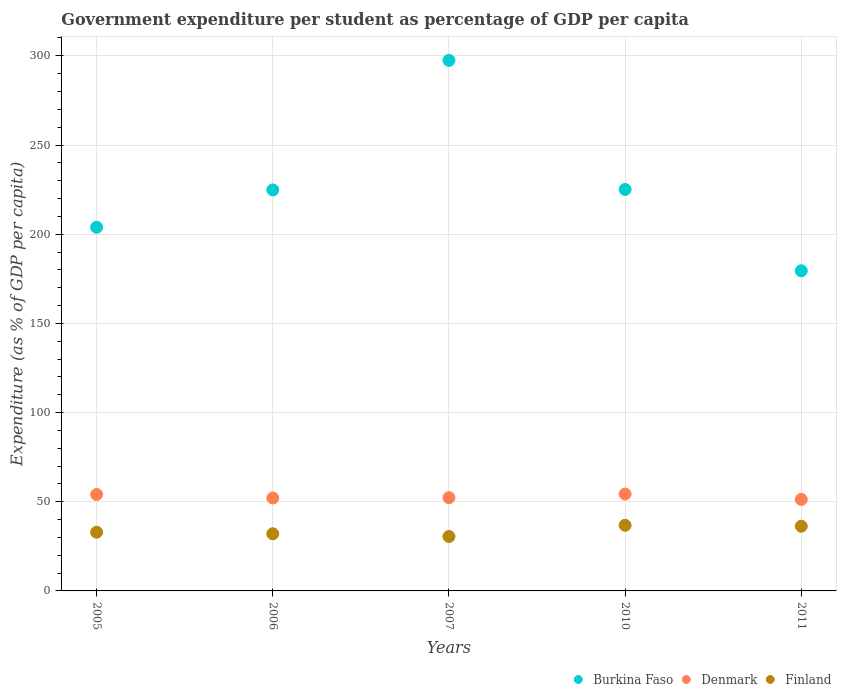How many different coloured dotlines are there?
Give a very brief answer. 3. Is the number of dotlines equal to the number of legend labels?
Your answer should be very brief. Yes. What is the percentage of expenditure per student in Finland in 2006?
Give a very brief answer. 32.04. Across all years, what is the maximum percentage of expenditure per student in Finland?
Your response must be concise. 36.8. Across all years, what is the minimum percentage of expenditure per student in Denmark?
Ensure brevity in your answer.  51.31. In which year was the percentage of expenditure per student in Burkina Faso minimum?
Keep it short and to the point. 2011. What is the total percentage of expenditure per student in Denmark in the graph?
Keep it short and to the point. 264.11. What is the difference between the percentage of expenditure per student in Finland in 2005 and that in 2006?
Give a very brief answer. 0.88. What is the difference between the percentage of expenditure per student in Finland in 2006 and the percentage of expenditure per student in Burkina Faso in 2011?
Ensure brevity in your answer.  -147.44. What is the average percentage of expenditure per student in Burkina Faso per year?
Keep it short and to the point. 226.14. In the year 2011, what is the difference between the percentage of expenditure per student in Denmark and percentage of expenditure per student in Burkina Faso?
Make the answer very short. -128.17. In how many years, is the percentage of expenditure per student in Burkina Faso greater than 230 %?
Your response must be concise. 1. What is the ratio of the percentage of expenditure per student in Denmark in 2010 to that in 2011?
Make the answer very short. 1.06. Is the percentage of expenditure per student in Finland in 2005 less than that in 2011?
Provide a short and direct response. Yes. Is the difference between the percentage of expenditure per student in Denmark in 2007 and 2010 greater than the difference between the percentage of expenditure per student in Burkina Faso in 2007 and 2010?
Offer a terse response. No. What is the difference between the highest and the second highest percentage of expenditure per student in Denmark?
Give a very brief answer. 0.23. What is the difference between the highest and the lowest percentage of expenditure per student in Denmark?
Your answer should be compact. 3.01. In how many years, is the percentage of expenditure per student in Finland greater than the average percentage of expenditure per student in Finland taken over all years?
Keep it short and to the point. 2. Is it the case that in every year, the sum of the percentage of expenditure per student in Burkina Faso and percentage of expenditure per student in Denmark  is greater than the percentage of expenditure per student in Finland?
Make the answer very short. Yes. Is the percentage of expenditure per student in Denmark strictly greater than the percentage of expenditure per student in Burkina Faso over the years?
Your answer should be compact. No. Is the percentage of expenditure per student in Burkina Faso strictly less than the percentage of expenditure per student in Finland over the years?
Offer a terse response. No. Does the graph contain any zero values?
Your response must be concise. No. What is the title of the graph?
Your answer should be very brief. Government expenditure per student as percentage of GDP per capita. Does "Greece" appear as one of the legend labels in the graph?
Keep it short and to the point. No. What is the label or title of the Y-axis?
Offer a very short reply. Expenditure (as % of GDP per capita). What is the Expenditure (as % of GDP per capita) of Burkina Faso in 2005?
Your answer should be compact. 203.88. What is the Expenditure (as % of GDP per capita) of Denmark in 2005?
Provide a short and direct response. 54.09. What is the Expenditure (as % of GDP per capita) in Finland in 2005?
Give a very brief answer. 32.92. What is the Expenditure (as % of GDP per capita) in Burkina Faso in 2006?
Offer a very short reply. 224.82. What is the Expenditure (as % of GDP per capita) of Denmark in 2006?
Make the answer very short. 52.1. What is the Expenditure (as % of GDP per capita) of Finland in 2006?
Your answer should be very brief. 32.04. What is the Expenditure (as % of GDP per capita) of Burkina Faso in 2007?
Give a very brief answer. 297.45. What is the Expenditure (as % of GDP per capita) in Denmark in 2007?
Ensure brevity in your answer.  52.29. What is the Expenditure (as % of GDP per capita) in Finland in 2007?
Provide a succinct answer. 30.51. What is the Expenditure (as % of GDP per capita) in Burkina Faso in 2010?
Your answer should be compact. 225.08. What is the Expenditure (as % of GDP per capita) in Denmark in 2010?
Ensure brevity in your answer.  54.32. What is the Expenditure (as % of GDP per capita) in Finland in 2010?
Your answer should be compact. 36.8. What is the Expenditure (as % of GDP per capita) of Burkina Faso in 2011?
Provide a short and direct response. 179.48. What is the Expenditure (as % of GDP per capita) of Denmark in 2011?
Provide a short and direct response. 51.31. What is the Expenditure (as % of GDP per capita) of Finland in 2011?
Provide a succinct answer. 36.27. Across all years, what is the maximum Expenditure (as % of GDP per capita) of Burkina Faso?
Your response must be concise. 297.45. Across all years, what is the maximum Expenditure (as % of GDP per capita) of Denmark?
Give a very brief answer. 54.32. Across all years, what is the maximum Expenditure (as % of GDP per capita) in Finland?
Your answer should be very brief. 36.8. Across all years, what is the minimum Expenditure (as % of GDP per capita) in Burkina Faso?
Your answer should be very brief. 179.48. Across all years, what is the minimum Expenditure (as % of GDP per capita) of Denmark?
Make the answer very short. 51.31. Across all years, what is the minimum Expenditure (as % of GDP per capita) of Finland?
Offer a very short reply. 30.51. What is the total Expenditure (as % of GDP per capita) in Burkina Faso in the graph?
Your answer should be compact. 1130.71. What is the total Expenditure (as % of GDP per capita) in Denmark in the graph?
Ensure brevity in your answer.  264.11. What is the total Expenditure (as % of GDP per capita) in Finland in the graph?
Your answer should be very brief. 168.54. What is the difference between the Expenditure (as % of GDP per capita) of Burkina Faso in 2005 and that in 2006?
Your answer should be compact. -20.94. What is the difference between the Expenditure (as % of GDP per capita) of Denmark in 2005 and that in 2006?
Your answer should be compact. 1.99. What is the difference between the Expenditure (as % of GDP per capita) in Finland in 2005 and that in 2006?
Give a very brief answer. 0.88. What is the difference between the Expenditure (as % of GDP per capita) in Burkina Faso in 2005 and that in 2007?
Keep it short and to the point. -93.57. What is the difference between the Expenditure (as % of GDP per capita) in Denmark in 2005 and that in 2007?
Your response must be concise. 1.8. What is the difference between the Expenditure (as % of GDP per capita) of Finland in 2005 and that in 2007?
Your answer should be compact. 2.41. What is the difference between the Expenditure (as % of GDP per capita) in Burkina Faso in 2005 and that in 2010?
Your response must be concise. -21.21. What is the difference between the Expenditure (as % of GDP per capita) in Denmark in 2005 and that in 2010?
Your answer should be very brief. -0.23. What is the difference between the Expenditure (as % of GDP per capita) in Finland in 2005 and that in 2010?
Your response must be concise. -3.89. What is the difference between the Expenditure (as % of GDP per capita) in Burkina Faso in 2005 and that in 2011?
Provide a short and direct response. 24.4. What is the difference between the Expenditure (as % of GDP per capita) of Denmark in 2005 and that in 2011?
Provide a short and direct response. 2.78. What is the difference between the Expenditure (as % of GDP per capita) of Finland in 2005 and that in 2011?
Ensure brevity in your answer.  -3.36. What is the difference between the Expenditure (as % of GDP per capita) in Burkina Faso in 2006 and that in 2007?
Give a very brief answer. -72.63. What is the difference between the Expenditure (as % of GDP per capita) of Denmark in 2006 and that in 2007?
Give a very brief answer. -0.19. What is the difference between the Expenditure (as % of GDP per capita) in Finland in 2006 and that in 2007?
Keep it short and to the point. 1.53. What is the difference between the Expenditure (as % of GDP per capita) in Burkina Faso in 2006 and that in 2010?
Provide a succinct answer. -0.26. What is the difference between the Expenditure (as % of GDP per capita) of Denmark in 2006 and that in 2010?
Give a very brief answer. -2.22. What is the difference between the Expenditure (as % of GDP per capita) in Finland in 2006 and that in 2010?
Provide a succinct answer. -4.77. What is the difference between the Expenditure (as % of GDP per capita) in Burkina Faso in 2006 and that in 2011?
Make the answer very short. 45.34. What is the difference between the Expenditure (as % of GDP per capita) of Denmark in 2006 and that in 2011?
Make the answer very short. 0.79. What is the difference between the Expenditure (as % of GDP per capita) of Finland in 2006 and that in 2011?
Provide a succinct answer. -4.24. What is the difference between the Expenditure (as % of GDP per capita) in Burkina Faso in 2007 and that in 2010?
Your answer should be very brief. 72.37. What is the difference between the Expenditure (as % of GDP per capita) of Denmark in 2007 and that in 2010?
Your answer should be very brief. -2.03. What is the difference between the Expenditure (as % of GDP per capita) in Finland in 2007 and that in 2010?
Give a very brief answer. -6.3. What is the difference between the Expenditure (as % of GDP per capita) of Burkina Faso in 2007 and that in 2011?
Your answer should be compact. 117.97. What is the difference between the Expenditure (as % of GDP per capita) of Denmark in 2007 and that in 2011?
Ensure brevity in your answer.  0.98. What is the difference between the Expenditure (as % of GDP per capita) of Finland in 2007 and that in 2011?
Keep it short and to the point. -5.77. What is the difference between the Expenditure (as % of GDP per capita) of Burkina Faso in 2010 and that in 2011?
Your answer should be very brief. 45.6. What is the difference between the Expenditure (as % of GDP per capita) of Denmark in 2010 and that in 2011?
Ensure brevity in your answer.  3.01. What is the difference between the Expenditure (as % of GDP per capita) in Finland in 2010 and that in 2011?
Keep it short and to the point. 0.53. What is the difference between the Expenditure (as % of GDP per capita) in Burkina Faso in 2005 and the Expenditure (as % of GDP per capita) in Denmark in 2006?
Offer a very short reply. 151.78. What is the difference between the Expenditure (as % of GDP per capita) in Burkina Faso in 2005 and the Expenditure (as % of GDP per capita) in Finland in 2006?
Provide a short and direct response. 171.84. What is the difference between the Expenditure (as % of GDP per capita) of Denmark in 2005 and the Expenditure (as % of GDP per capita) of Finland in 2006?
Provide a short and direct response. 22.05. What is the difference between the Expenditure (as % of GDP per capita) of Burkina Faso in 2005 and the Expenditure (as % of GDP per capita) of Denmark in 2007?
Your answer should be compact. 151.59. What is the difference between the Expenditure (as % of GDP per capita) in Burkina Faso in 2005 and the Expenditure (as % of GDP per capita) in Finland in 2007?
Keep it short and to the point. 173.37. What is the difference between the Expenditure (as % of GDP per capita) of Denmark in 2005 and the Expenditure (as % of GDP per capita) of Finland in 2007?
Provide a short and direct response. 23.58. What is the difference between the Expenditure (as % of GDP per capita) of Burkina Faso in 2005 and the Expenditure (as % of GDP per capita) of Denmark in 2010?
Provide a succinct answer. 149.56. What is the difference between the Expenditure (as % of GDP per capita) of Burkina Faso in 2005 and the Expenditure (as % of GDP per capita) of Finland in 2010?
Offer a very short reply. 167.07. What is the difference between the Expenditure (as % of GDP per capita) of Denmark in 2005 and the Expenditure (as % of GDP per capita) of Finland in 2010?
Your answer should be compact. 17.28. What is the difference between the Expenditure (as % of GDP per capita) in Burkina Faso in 2005 and the Expenditure (as % of GDP per capita) in Denmark in 2011?
Give a very brief answer. 152.57. What is the difference between the Expenditure (as % of GDP per capita) in Burkina Faso in 2005 and the Expenditure (as % of GDP per capita) in Finland in 2011?
Ensure brevity in your answer.  167.6. What is the difference between the Expenditure (as % of GDP per capita) of Denmark in 2005 and the Expenditure (as % of GDP per capita) of Finland in 2011?
Ensure brevity in your answer.  17.81. What is the difference between the Expenditure (as % of GDP per capita) of Burkina Faso in 2006 and the Expenditure (as % of GDP per capita) of Denmark in 2007?
Your response must be concise. 172.53. What is the difference between the Expenditure (as % of GDP per capita) of Burkina Faso in 2006 and the Expenditure (as % of GDP per capita) of Finland in 2007?
Give a very brief answer. 194.31. What is the difference between the Expenditure (as % of GDP per capita) of Denmark in 2006 and the Expenditure (as % of GDP per capita) of Finland in 2007?
Make the answer very short. 21.6. What is the difference between the Expenditure (as % of GDP per capita) in Burkina Faso in 2006 and the Expenditure (as % of GDP per capita) in Denmark in 2010?
Provide a short and direct response. 170.5. What is the difference between the Expenditure (as % of GDP per capita) of Burkina Faso in 2006 and the Expenditure (as % of GDP per capita) of Finland in 2010?
Your answer should be compact. 188.02. What is the difference between the Expenditure (as % of GDP per capita) in Denmark in 2006 and the Expenditure (as % of GDP per capita) in Finland in 2010?
Your answer should be compact. 15.3. What is the difference between the Expenditure (as % of GDP per capita) in Burkina Faso in 2006 and the Expenditure (as % of GDP per capita) in Denmark in 2011?
Offer a terse response. 173.51. What is the difference between the Expenditure (as % of GDP per capita) in Burkina Faso in 2006 and the Expenditure (as % of GDP per capita) in Finland in 2011?
Make the answer very short. 188.55. What is the difference between the Expenditure (as % of GDP per capita) of Denmark in 2006 and the Expenditure (as % of GDP per capita) of Finland in 2011?
Provide a succinct answer. 15.83. What is the difference between the Expenditure (as % of GDP per capita) in Burkina Faso in 2007 and the Expenditure (as % of GDP per capita) in Denmark in 2010?
Offer a terse response. 243.13. What is the difference between the Expenditure (as % of GDP per capita) of Burkina Faso in 2007 and the Expenditure (as % of GDP per capita) of Finland in 2010?
Keep it short and to the point. 260.65. What is the difference between the Expenditure (as % of GDP per capita) of Denmark in 2007 and the Expenditure (as % of GDP per capita) of Finland in 2010?
Provide a short and direct response. 15.48. What is the difference between the Expenditure (as % of GDP per capita) in Burkina Faso in 2007 and the Expenditure (as % of GDP per capita) in Denmark in 2011?
Your response must be concise. 246.14. What is the difference between the Expenditure (as % of GDP per capita) of Burkina Faso in 2007 and the Expenditure (as % of GDP per capita) of Finland in 2011?
Offer a terse response. 261.18. What is the difference between the Expenditure (as % of GDP per capita) of Denmark in 2007 and the Expenditure (as % of GDP per capita) of Finland in 2011?
Offer a terse response. 16.01. What is the difference between the Expenditure (as % of GDP per capita) of Burkina Faso in 2010 and the Expenditure (as % of GDP per capita) of Denmark in 2011?
Ensure brevity in your answer.  173.77. What is the difference between the Expenditure (as % of GDP per capita) of Burkina Faso in 2010 and the Expenditure (as % of GDP per capita) of Finland in 2011?
Offer a very short reply. 188.81. What is the difference between the Expenditure (as % of GDP per capita) of Denmark in 2010 and the Expenditure (as % of GDP per capita) of Finland in 2011?
Your response must be concise. 18.05. What is the average Expenditure (as % of GDP per capita) in Burkina Faso per year?
Offer a terse response. 226.14. What is the average Expenditure (as % of GDP per capita) of Denmark per year?
Provide a succinct answer. 52.82. What is the average Expenditure (as % of GDP per capita) of Finland per year?
Ensure brevity in your answer.  33.71. In the year 2005, what is the difference between the Expenditure (as % of GDP per capita) in Burkina Faso and Expenditure (as % of GDP per capita) in Denmark?
Offer a terse response. 149.79. In the year 2005, what is the difference between the Expenditure (as % of GDP per capita) of Burkina Faso and Expenditure (as % of GDP per capita) of Finland?
Offer a very short reply. 170.96. In the year 2005, what is the difference between the Expenditure (as % of GDP per capita) of Denmark and Expenditure (as % of GDP per capita) of Finland?
Your answer should be compact. 21.17. In the year 2006, what is the difference between the Expenditure (as % of GDP per capita) in Burkina Faso and Expenditure (as % of GDP per capita) in Denmark?
Offer a terse response. 172.72. In the year 2006, what is the difference between the Expenditure (as % of GDP per capita) of Burkina Faso and Expenditure (as % of GDP per capita) of Finland?
Provide a short and direct response. 192.78. In the year 2006, what is the difference between the Expenditure (as % of GDP per capita) in Denmark and Expenditure (as % of GDP per capita) in Finland?
Ensure brevity in your answer.  20.07. In the year 2007, what is the difference between the Expenditure (as % of GDP per capita) in Burkina Faso and Expenditure (as % of GDP per capita) in Denmark?
Provide a succinct answer. 245.16. In the year 2007, what is the difference between the Expenditure (as % of GDP per capita) in Burkina Faso and Expenditure (as % of GDP per capita) in Finland?
Your response must be concise. 266.95. In the year 2007, what is the difference between the Expenditure (as % of GDP per capita) in Denmark and Expenditure (as % of GDP per capita) in Finland?
Provide a short and direct response. 21.78. In the year 2010, what is the difference between the Expenditure (as % of GDP per capita) of Burkina Faso and Expenditure (as % of GDP per capita) of Denmark?
Provide a short and direct response. 170.76. In the year 2010, what is the difference between the Expenditure (as % of GDP per capita) of Burkina Faso and Expenditure (as % of GDP per capita) of Finland?
Ensure brevity in your answer.  188.28. In the year 2010, what is the difference between the Expenditure (as % of GDP per capita) of Denmark and Expenditure (as % of GDP per capita) of Finland?
Provide a short and direct response. 17.52. In the year 2011, what is the difference between the Expenditure (as % of GDP per capita) in Burkina Faso and Expenditure (as % of GDP per capita) in Denmark?
Provide a succinct answer. 128.17. In the year 2011, what is the difference between the Expenditure (as % of GDP per capita) of Burkina Faso and Expenditure (as % of GDP per capita) of Finland?
Provide a succinct answer. 143.21. In the year 2011, what is the difference between the Expenditure (as % of GDP per capita) in Denmark and Expenditure (as % of GDP per capita) in Finland?
Make the answer very short. 15.04. What is the ratio of the Expenditure (as % of GDP per capita) of Burkina Faso in 2005 to that in 2006?
Give a very brief answer. 0.91. What is the ratio of the Expenditure (as % of GDP per capita) of Denmark in 2005 to that in 2006?
Provide a short and direct response. 1.04. What is the ratio of the Expenditure (as % of GDP per capita) in Finland in 2005 to that in 2006?
Your answer should be very brief. 1.03. What is the ratio of the Expenditure (as % of GDP per capita) in Burkina Faso in 2005 to that in 2007?
Provide a succinct answer. 0.69. What is the ratio of the Expenditure (as % of GDP per capita) of Denmark in 2005 to that in 2007?
Keep it short and to the point. 1.03. What is the ratio of the Expenditure (as % of GDP per capita) in Finland in 2005 to that in 2007?
Your response must be concise. 1.08. What is the ratio of the Expenditure (as % of GDP per capita) in Burkina Faso in 2005 to that in 2010?
Your response must be concise. 0.91. What is the ratio of the Expenditure (as % of GDP per capita) in Finland in 2005 to that in 2010?
Your answer should be very brief. 0.89. What is the ratio of the Expenditure (as % of GDP per capita) of Burkina Faso in 2005 to that in 2011?
Your answer should be compact. 1.14. What is the ratio of the Expenditure (as % of GDP per capita) of Denmark in 2005 to that in 2011?
Provide a short and direct response. 1.05. What is the ratio of the Expenditure (as % of GDP per capita) in Finland in 2005 to that in 2011?
Give a very brief answer. 0.91. What is the ratio of the Expenditure (as % of GDP per capita) in Burkina Faso in 2006 to that in 2007?
Your answer should be very brief. 0.76. What is the ratio of the Expenditure (as % of GDP per capita) of Denmark in 2006 to that in 2007?
Your response must be concise. 1. What is the ratio of the Expenditure (as % of GDP per capita) of Finland in 2006 to that in 2007?
Your answer should be compact. 1.05. What is the ratio of the Expenditure (as % of GDP per capita) in Burkina Faso in 2006 to that in 2010?
Offer a terse response. 1. What is the ratio of the Expenditure (as % of GDP per capita) of Denmark in 2006 to that in 2010?
Your answer should be compact. 0.96. What is the ratio of the Expenditure (as % of GDP per capita) in Finland in 2006 to that in 2010?
Offer a terse response. 0.87. What is the ratio of the Expenditure (as % of GDP per capita) of Burkina Faso in 2006 to that in 2011?
Provide a short and direct response. 1.25. What is the ratio of the Expenditure (as % of GDP per capita) of Denmark in 2006 to that in 2011?
Offer a very short reply. 1.02. What is the ratio of the Expenditure (as % of GDP per capita) of Finland in 2006 to that in 2011?
Ensure brevity in your answer.  0.88. What is the ratio of the Expenditure (as % of GDP per capita) of Burkina Faso in 2007 to that in 2010?
Offer a very short reply. 1.32. What is the ratio of the Expenditure (as % of GDP per capita) of Denmark in 2007 to that in 2010?
Your response must be concise. 0.96. What is the ratio of the Expenditure (as % of GDP per capita) in Finland in 2007 to that in 2010?
Offer a very short reply. 0.83. What is the ratio of the Expenditure (as % of GDP per capita) in Burkina Faso in 2007 to that in 2011?
Provide a short and direct response. 1.66. What is the ratio of the Expenditure (as % of GDP per capita) of Finland in 2007 to that in 2011?
Your answer should be very brief. 0.84. What is the ratio of the Expenditure (as % of GDP per capita) of Burkina Faso in 2010 to that in 2011?
Provide a short and direct response. 1.25. What is the ratio of the Expenditure (as % of GDP per capita) in Denmark in 2010 to that in 2011?
Keep it short and to the point. 1.06. What is the ratio of the Expenditure (as % of GDP per capita) in Finland in 2010 to that in 2011?
Keep it short and to the point. 1.01. What is the difference between the highest and the second highest Expenditure (as % of GDP per capita) in Burkina Faso?
Make the answer very short. 72.37. What is the difference between the highest and the second highest Expenditure (as % of GDP per capita) of Denmark?
Give a very brief answer. 0.23. What is the difference between the highest and the second highest Expenditure (as % of GDP per capita) of Finland?
Your answer should be compact. 0.53. What is the difference between the highest and the lowest Expenditure (as % of GDP per capita) in Burkina Faso?
Keep it short and to the point. 117.97. What is the difference between the highest and the lowest Expenditure (as % of GDP per capita) of Denmark?
Give a very brief answer. 3.01. What is the difference between the highest and the lowest Expenditure (as % of GDP per capita) in Finland?
Your answer should be compact. 6.3. 